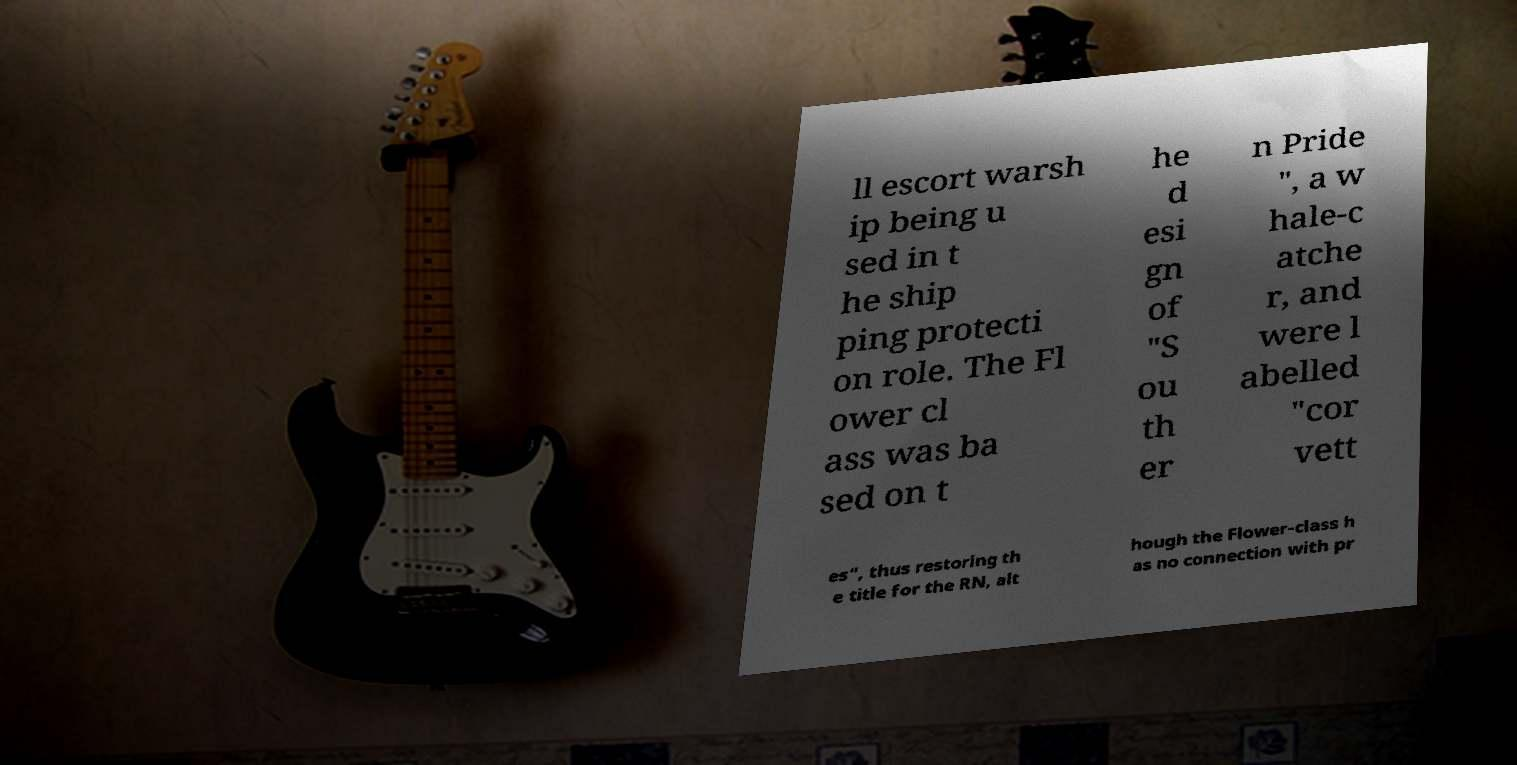What messages or text are displayed in this image? I need them in a readable, typed format. ll escort warsh ip being u sed in t he ship ping protecti on role. The Fl ower cl ass was ba sed on t he d esi gn of "S ou th er n Pride ", a w hale-c atche r, and were l abelled "cor vett es", thus restoring th e title for the RN, alt hough the Flower-class h as no connection with pr 